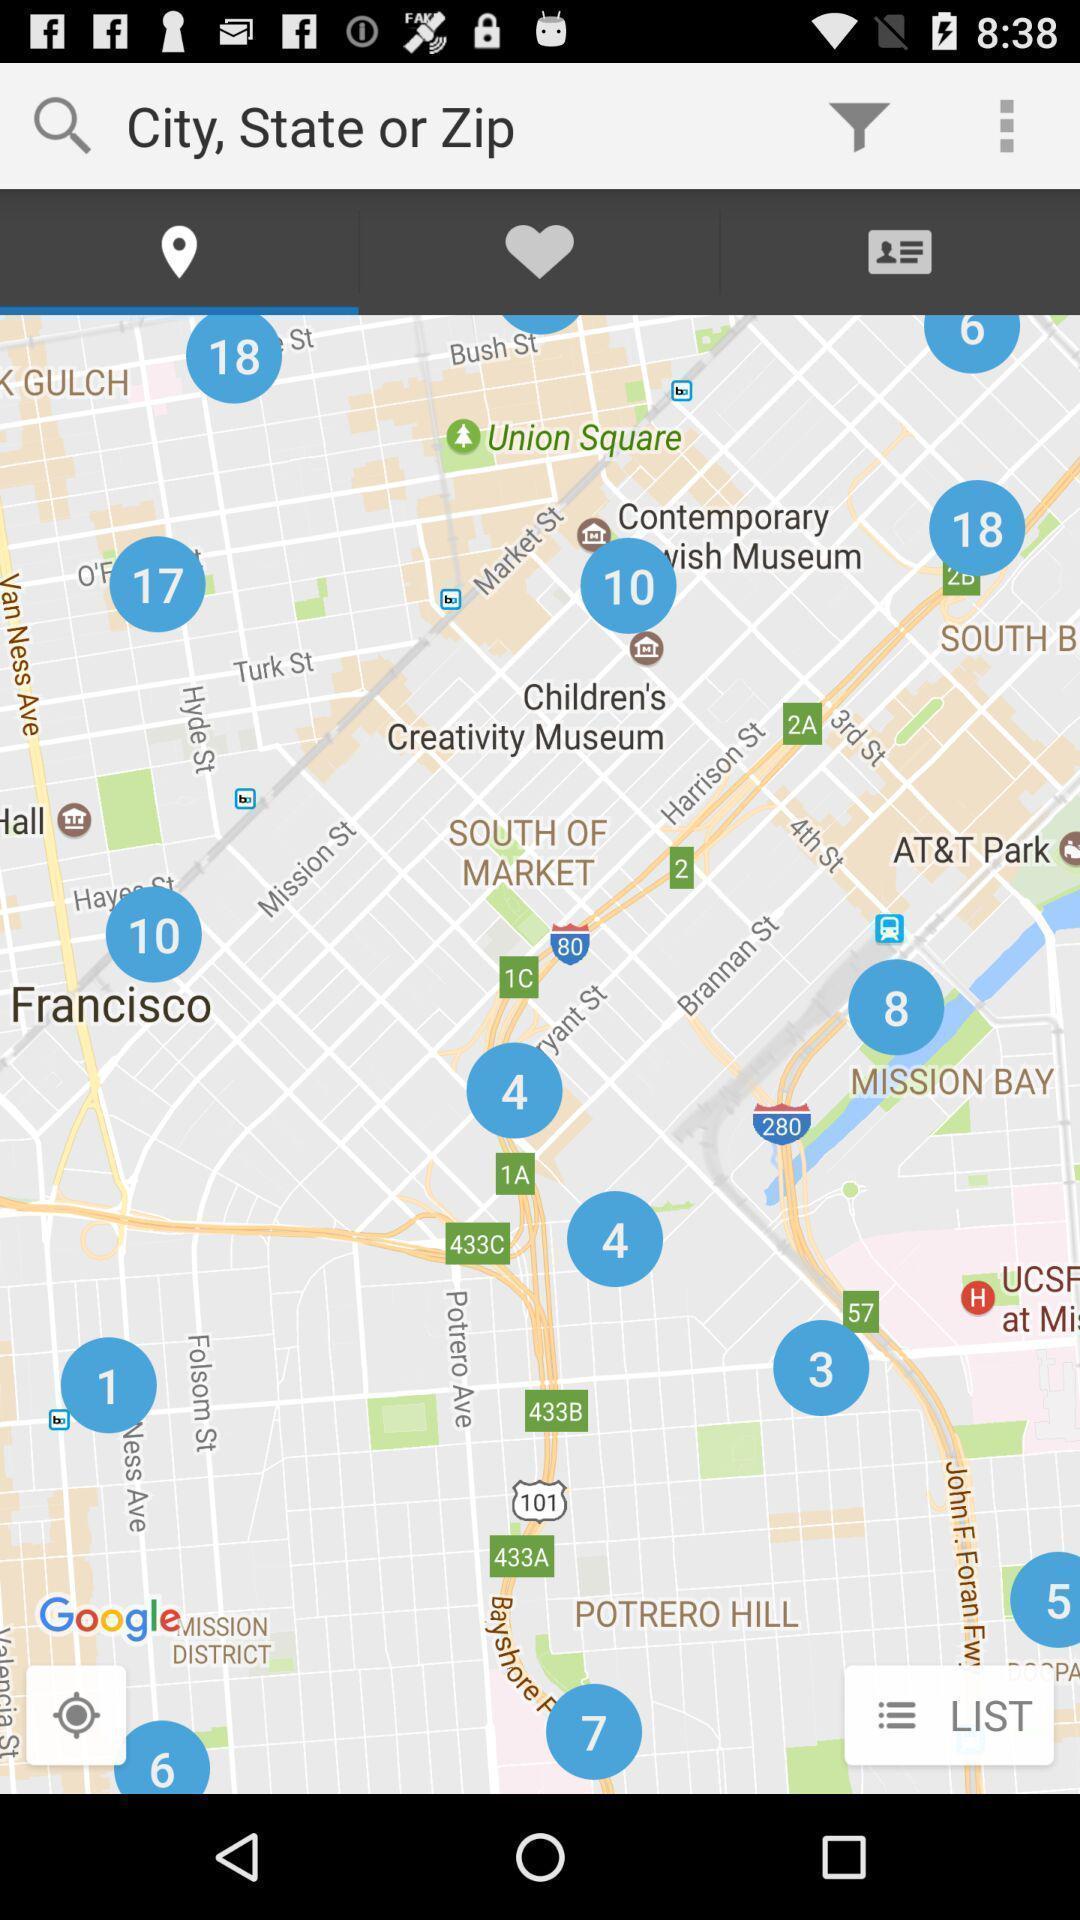Describe this image in words. Page for searching locations for apartments. 